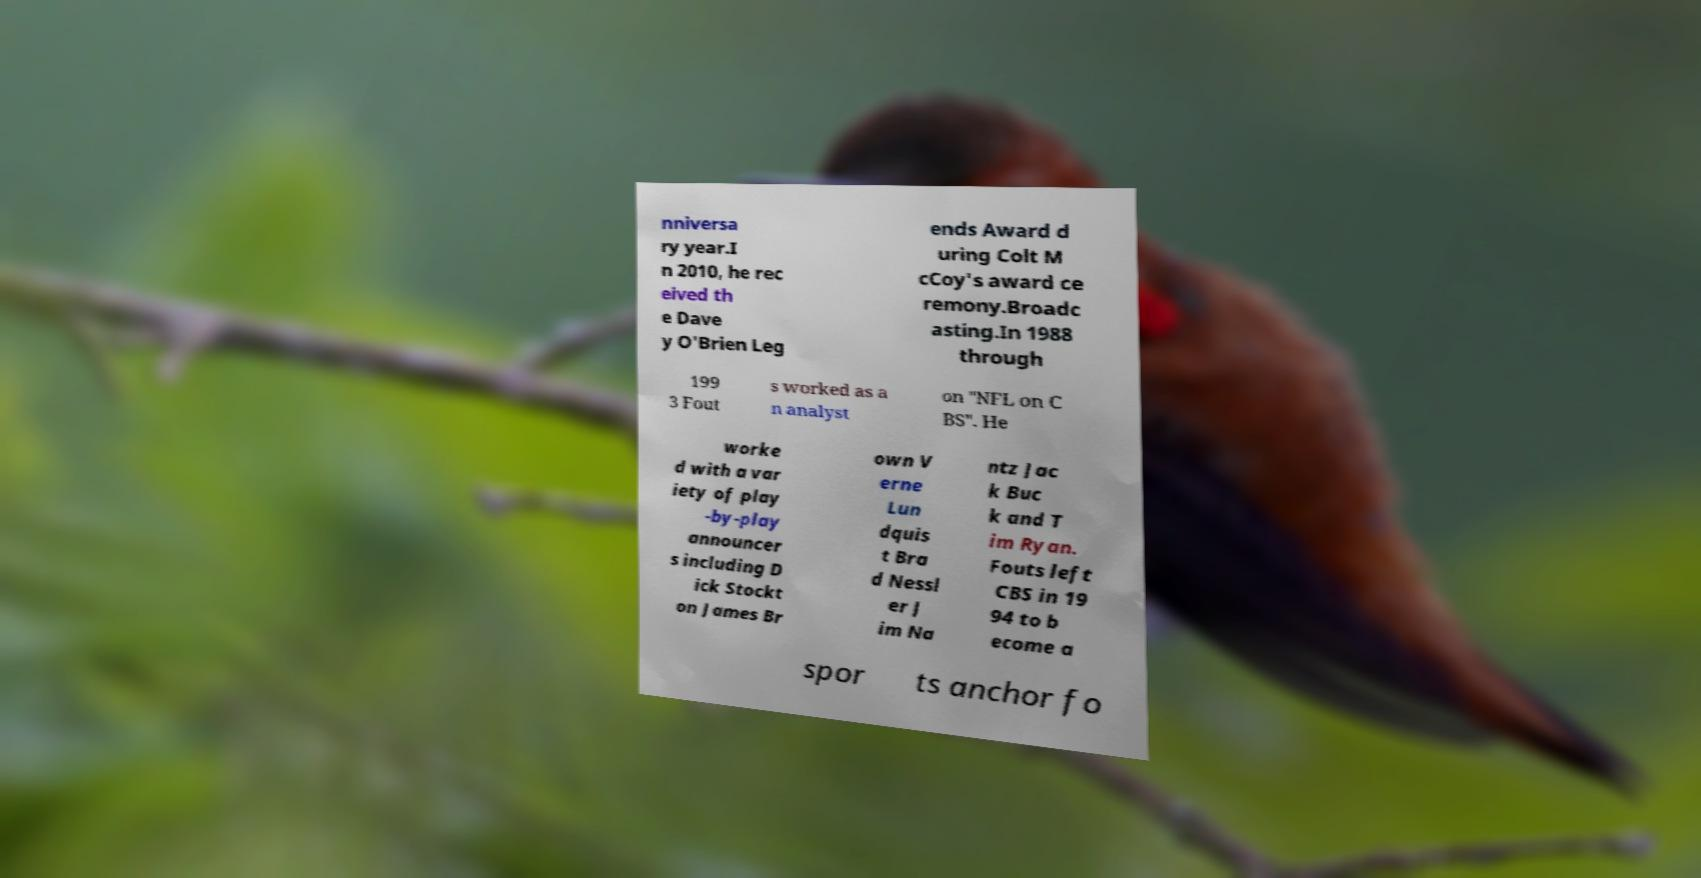There's text embedded in this image that I need extracted. Can you transcribe it verbatim? nniversa ry year.I n 2010, he rec eived th e Dave y O'Brien Leg ends Award d uring Colt M cCoy's award ce remony.Broadc asting.In 1988 through 199 3 Fout s worked as a n analyst on "NFL on C BS". He worke d with a var iety of play -by-play announcer s including D ick Stockt on James Br own V erne Lun dquis t Bra d Nessl er J im Na ntz Jac k Buc k and T im Ryan. Fouts left CBS in 19 94 to b ecome a spor ts anchor fo 